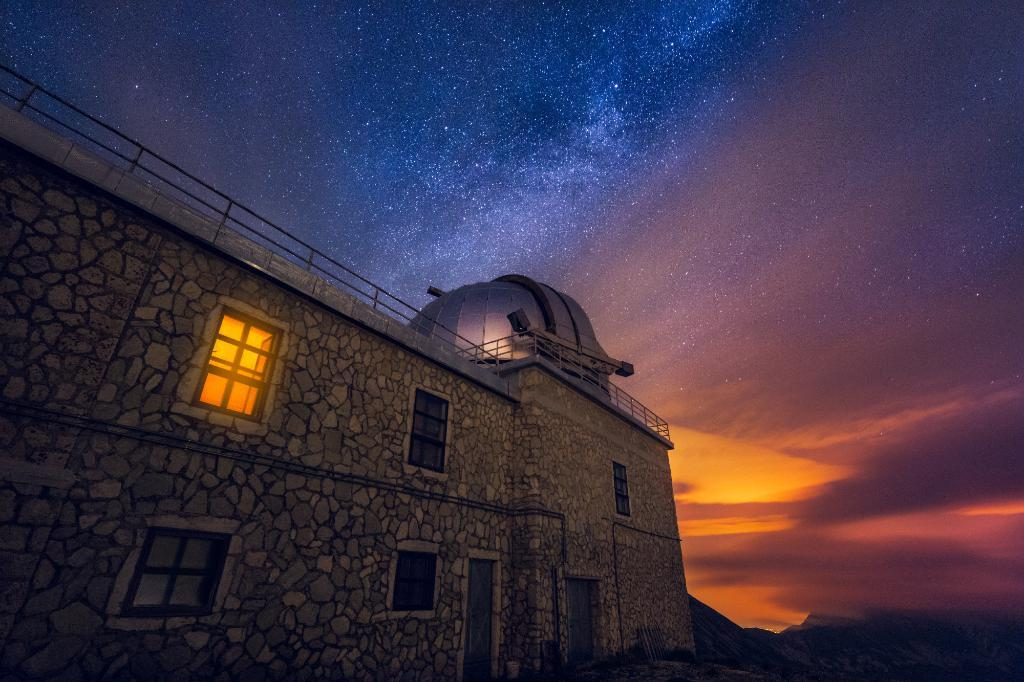What is the main subject in the foreground of the picture? There is a building in the foreground of the picture. What features can be observed on the building? The building has windows and a door. What can be seen in the background of the image? The sky is colorful in the image. What direction is the rifle pointing in the image? There is no rifle present in the image. What topics are being discussed by the people in the image? There are no people present in the image, so there is no discussion taking place. 